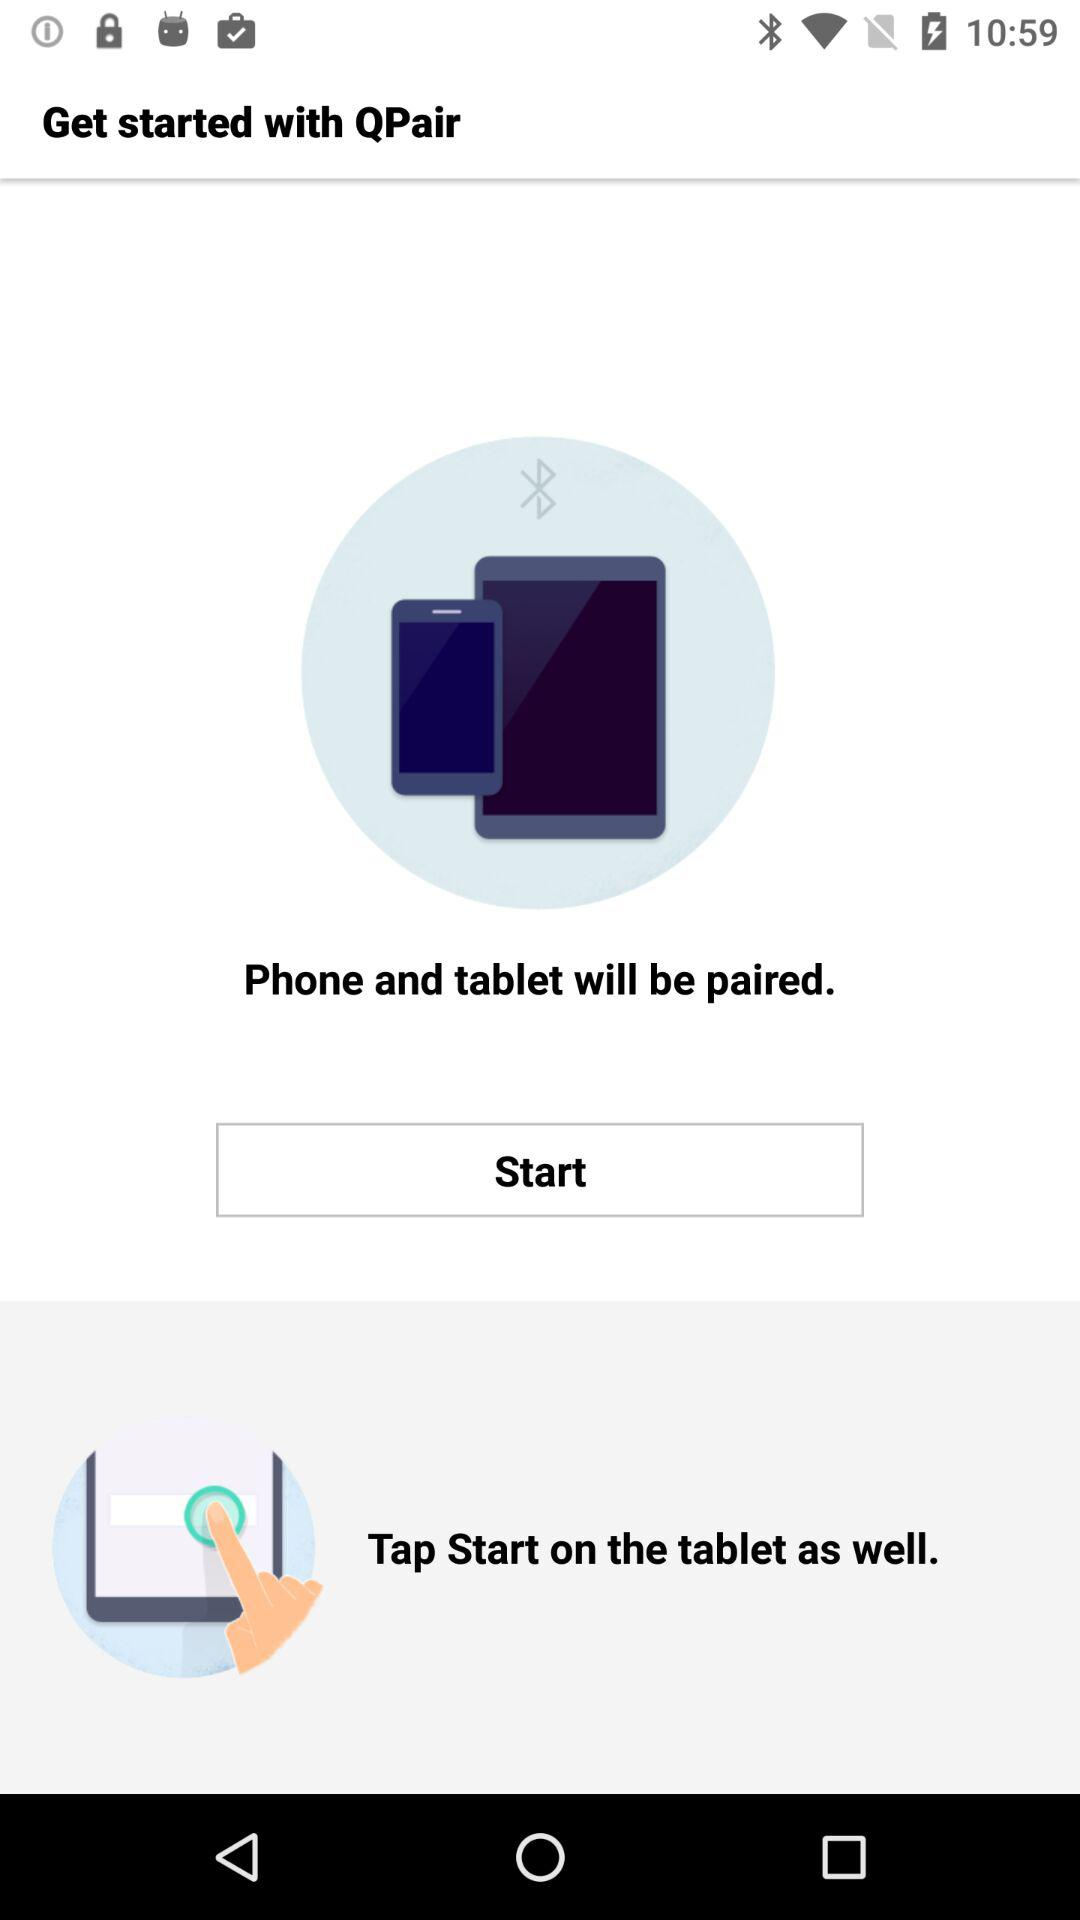How many more steps do I have to complete to get started?
Answer the question using a single word or phrase. 1 